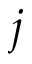Convert formula to latex. <formula><loc_0><loc_0><loc_500><loc_500>j</formula> 